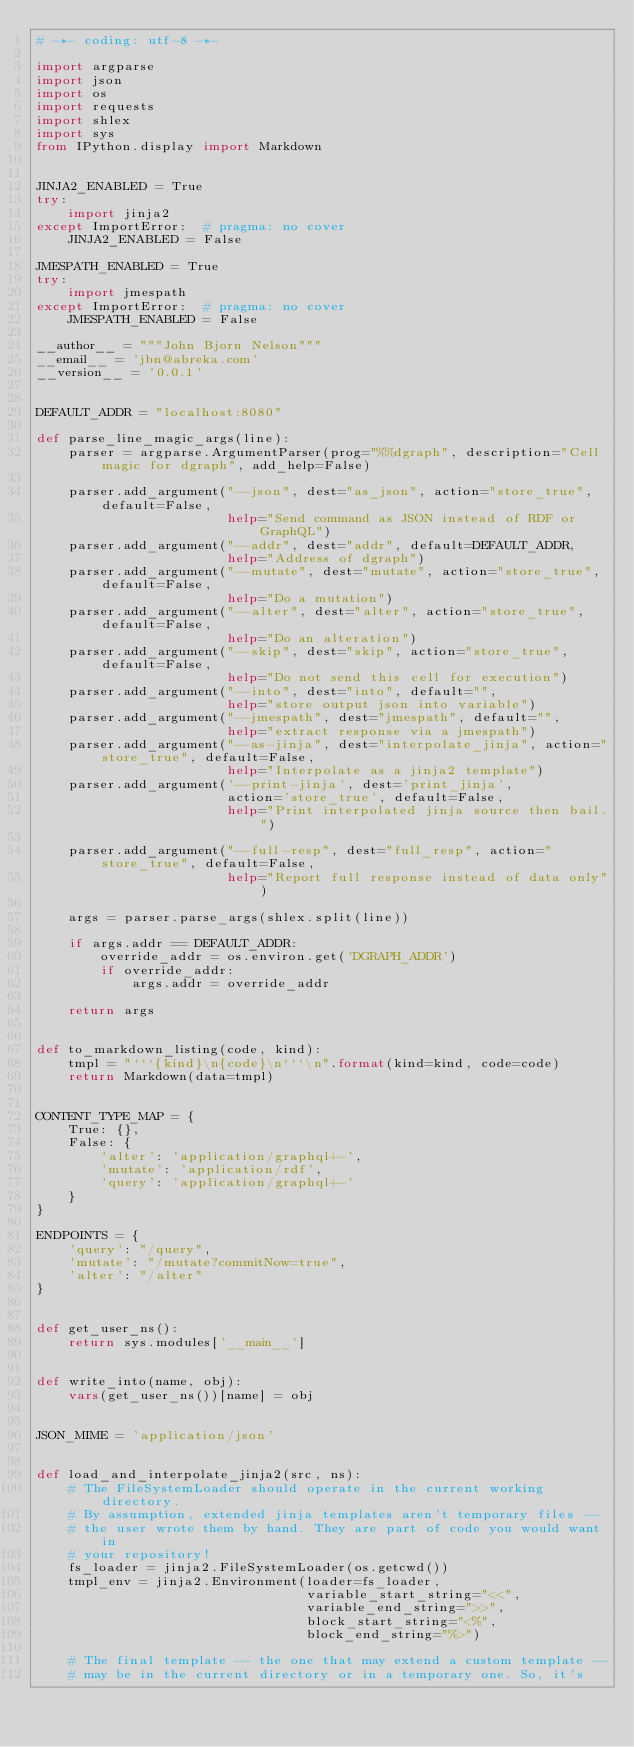<code> <loc_0><loc_0><loc_500><loc_500><_Python_># -*- coding: utf-8 -*-

import argparse
import json
import os
import requests
import shlex
import sys
from IPython.display import Markdown


JINJA2_ENABLED = True
try:
    import jinja2
except ImportError:  # pragma: no cover
    JINJA2_ENABLED = False

JMESPATH_ENABLED = True
try:
    import jmespath
except ImportError:  # pragma: no cover
    JMESPATH_ENABLED = False

__author__ = """John Bjorn Nelson"""
__email__ = 'jbn@abreka.com'
__version__ = '0.0.1'


DEFAULT_ADDR = "localhost:8080"

def parse_line_magic_args(line):
    parser = argparse.ArgumentParser(prog="%%dgraph", description="Cell magic for dgraph", add_help=False)

    parser.add_argument("--json", dest="as_json", action="store_true", default=False,
                        help="Send command as JSON instead of RDF or GraphQL")
    parser.add_argument("--addr", dest="addr", default=DEFAULT_ADDR,
                        help="Address of dgraph")
    parser.add_argument("--mutate", dest="mutate", action="store_true", default=False,
                        help="Do a mutation")
    parser.add_argument("--alter", dest="alter", action="store_true", default=False,
                        help="Do an alteration")
    parser.add_argument("--skip", dest="skip", action="store_true", default=False,
                        help="Do not send this cell for execution")
    parser.add_argument("--into", dest="into", default="",
                        help="store output json into variable")
    parser.add_argument("--jmespath", dest="jmespath", default="",
                        help="extract response via a jmespath")
    parser.add_argument("--as-jinja", dest="interpolate_jinja", action="store_true", default=False,
                        help="Interpolate as a jinja2 template")
    parser.add_argument('--print-jinja', dest='print_jinja',
                        action='store_true', default=False,
                        help="Print interpolated jinja source then bail.")

    parser.add_argument("--full-resp", dest="full_resp", action="store_true", default=False,
                        help="Report full response instead of data only")

    args = parser.parse_args(shlex.split(line))

    if args.addr == DEFAULT_ADDR:
        override_addr = os.environ.get('DGRAPH_ADDR')
        if override_addr:
            args.addr = override_addr

    return args


def to_markdown_listing(code, kind):
    tmpl = "```{kind}\n{code}\n```\n".format(kind=kind, code=code)
    return Markdown(data=tmpl)


CONTENT_TYPE_MAP = {
    True: {},
    False: {
        'alter': 'application/graphql+-',
        'mutate': 'application/rdf',
        'query': 'application/graphql+-'
    }
}

ENDPOINTS = {
    'query': "/query",
    'mutate': "/mutate?commitNow=true",
    'alter': "/alter"
}


def get_user_ns():
    return sys.modules['__main__']


def write_into(name, obj):
    vars(get_user_ns())[name] = obj


JSON_MIME = 'application/json'


def load_and_interpolate_jinja2(src, ns):
    # The FileSystemLoader should operate in the current working directory.
    # By assumption, extended jinja templates aren't temporary files --
    # the user wrote them by hand. They are part of code you would want in
    # your repository!
    fs_loader = jinja2.FileSystemLoader(os.getcwd())
    tmpl_env = jinja2.Environment(loader=fs_loader,
                                  variable_start_string="<<",
                                  variable_end_string=">>",
                                  block_start_string="<%",
                                  block_end_string="%>")

    # The final template -- the one that may extend a custom template --
    # may be in the current directory or in a temporary one. So, it's</code> 